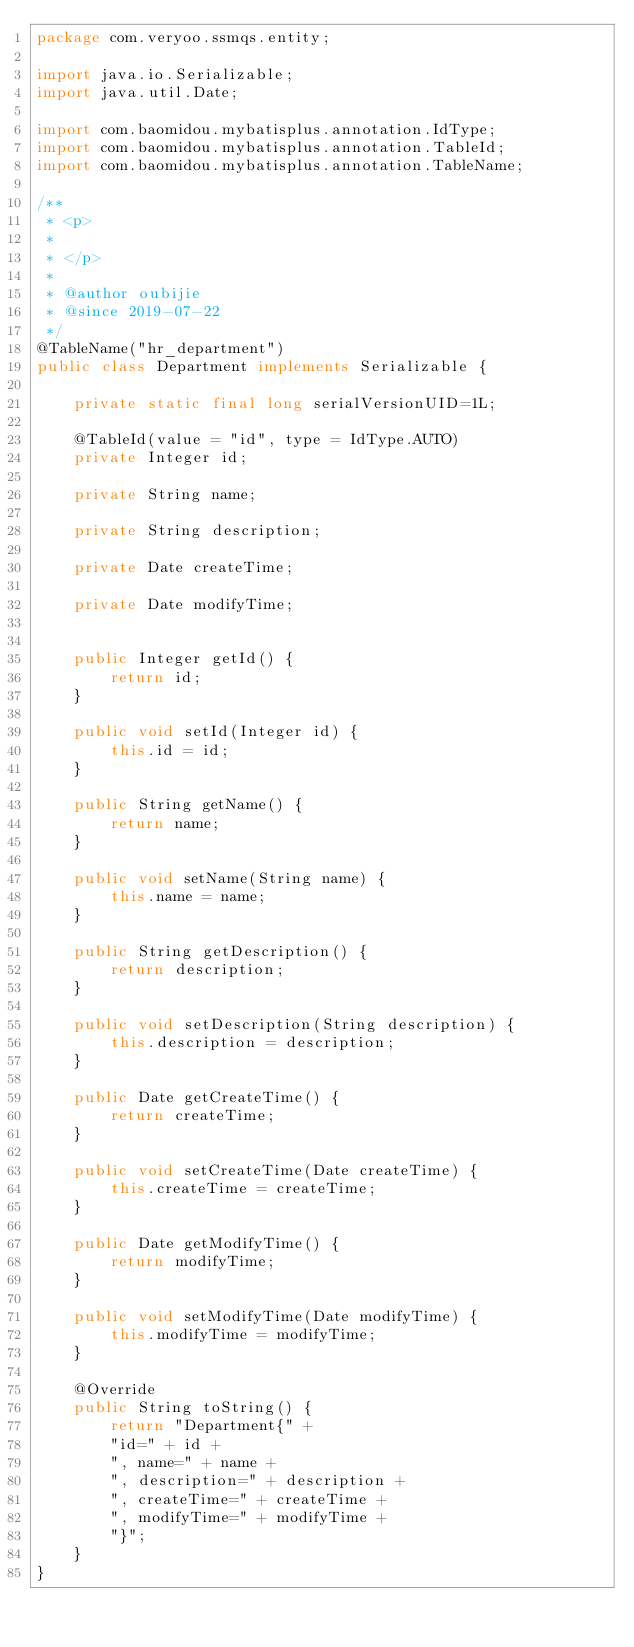Convert code to text. <code><loc_0><loc_0><loc_500><loc_500><_Java_>package com.veryoo.ssmqs.entity;

import java.io.Serializable;
import java.util.Date;

import com.baomidou.mybatisplus.annotation.IdType;
import com.baomidou.mybatisplus.annotation.TableId;
import com.baomidou.mybatisplus.annotation.TableName;

/**
 * <p>
 * 
 * </p>
 *
 * @author oubijie
 * @since 2019-07-22
 */
@TableName("hr_department")
public class Department implements Serializable {

    private static final long serialVersionUID=1L;

    @TableId(value = "id", type = IdType.AUTO)
    private Integer id;

    private String name;

    private String description;

    private Date createTime;

    private Date modifyTime;


    public Integer getId() {
        return id;
    }

    public void setId(Integer id) {
        this.id = id;
    }

    public String getName() {
        return name;
    }

    public void setName(String name) {
        this.name = name;
    }

    public String getDescription() {
        return description;
    }

    public void setDescription(String description) {
        this.description = description;
    }

    public Date getCreateTime() {
        return createTime;
    }

    public void setCreateTime(Date createTime) {
        this.createTime = createTime;
    }

    public Date getModifyTime() {
        return modifyTime;
    }

    public void setModifyTime(Date modifyTime) {
        this.modifyTime = modifyTime;
    }

    @Override
    public String toString() {
        return "Department{" +
        "id=" + id +
        ", name=" + name +
        ", description=" + description +
        ", createTime=" + createTime +
        ", modifyTime=" + modifyTime +
        "}";
    }
}
</code> 